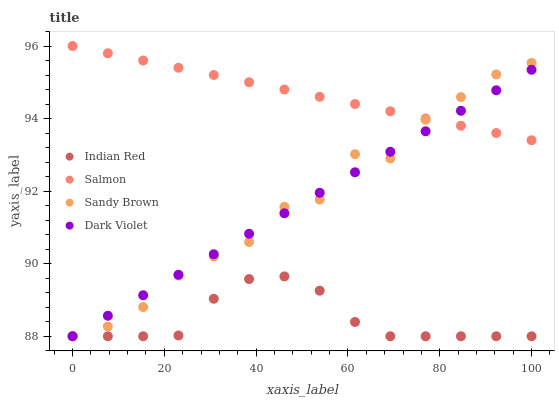Does Indian Red have the minimum area under the curve?
Answer yes or no. Yes. Does Salmon have the maximum area under the curve?
Answer yes or no. Yes. Does Dark Violet have the minimum area under the curve?
Answer yes or no. No. Does Dark Violet have the maximum area under the curve?
Answer yes or no. No. Is Dark Violet the smoothest?
Answer yes or no. Yes. Is Sandy Brown the roughest?
Answer yes or no. Yes. Is Salmon the smoothest?
Answer yes or no. No. Is Salmon the roughest?
Answer yes or no. No. Does Sandy Brown have the lowest value?
Answer yes or no. Yes. Does Salmon have the lowest value?
Answer yes or no. No. Does Salmon have the highest value?
Answer yes or no. Yes. Does Dark Violet have the highest value?
Answer yes or no. No. Is Indian Red less than Salmon?
Answer yes or no. Yes. Is Salmon greater than Indian Red?
Answer yes or no. Yes. Does Salmon intersect Sandy Brown?
Answer yes or no. Yes. Is Salmon less than Sandy Brown?
Answer yes or no. No. Is Salmon greater than Sandy Brown?
Answer yes or no. No. Does Indian Red intersect Salmon?
Answer yes or no. No. 